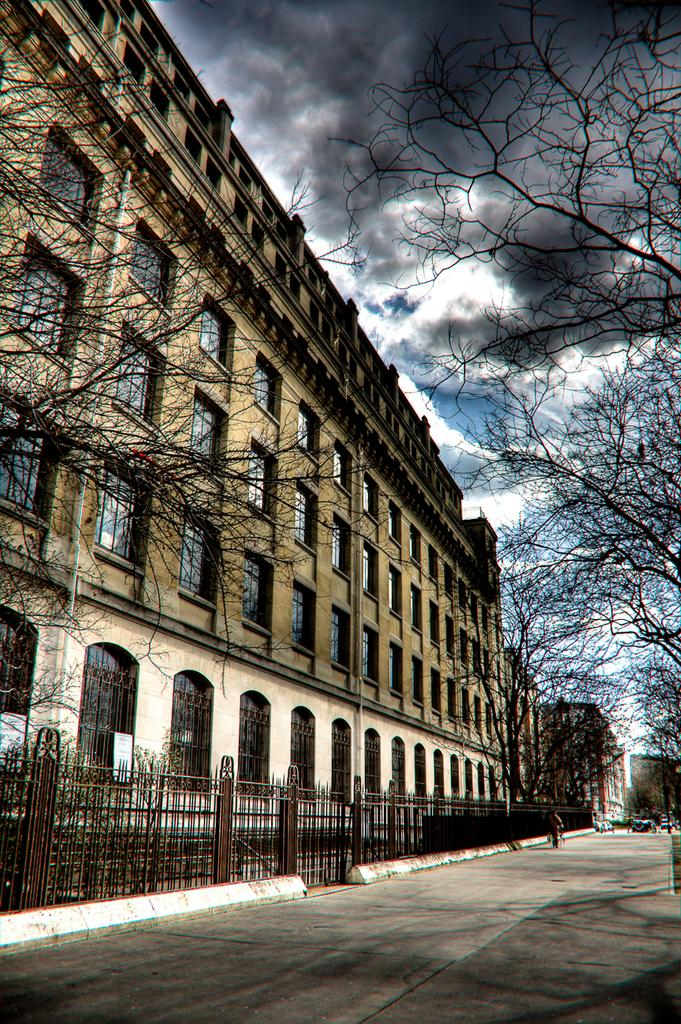What type of structures are present in the image? There is a group of buildings in the image. What feature do the buildings have? The buildings have windows. What is blocking the pathway in the image? There is a barricade in the image. What can be seen on the ground in the image? There is a pathway in the image. What type of vegetation is visible in the background of the image? There is a group of trees in the background of the image. How would you describe the weather based on the image? The sky is a cloudy sky visible in the background of the image, suggesting a potentially overcast or cloudy day. Can you tell me how many flowers are being cooked by the stranger in the image? There is no stranger or flowers present in the image, and therefore no such activity can be observed. 